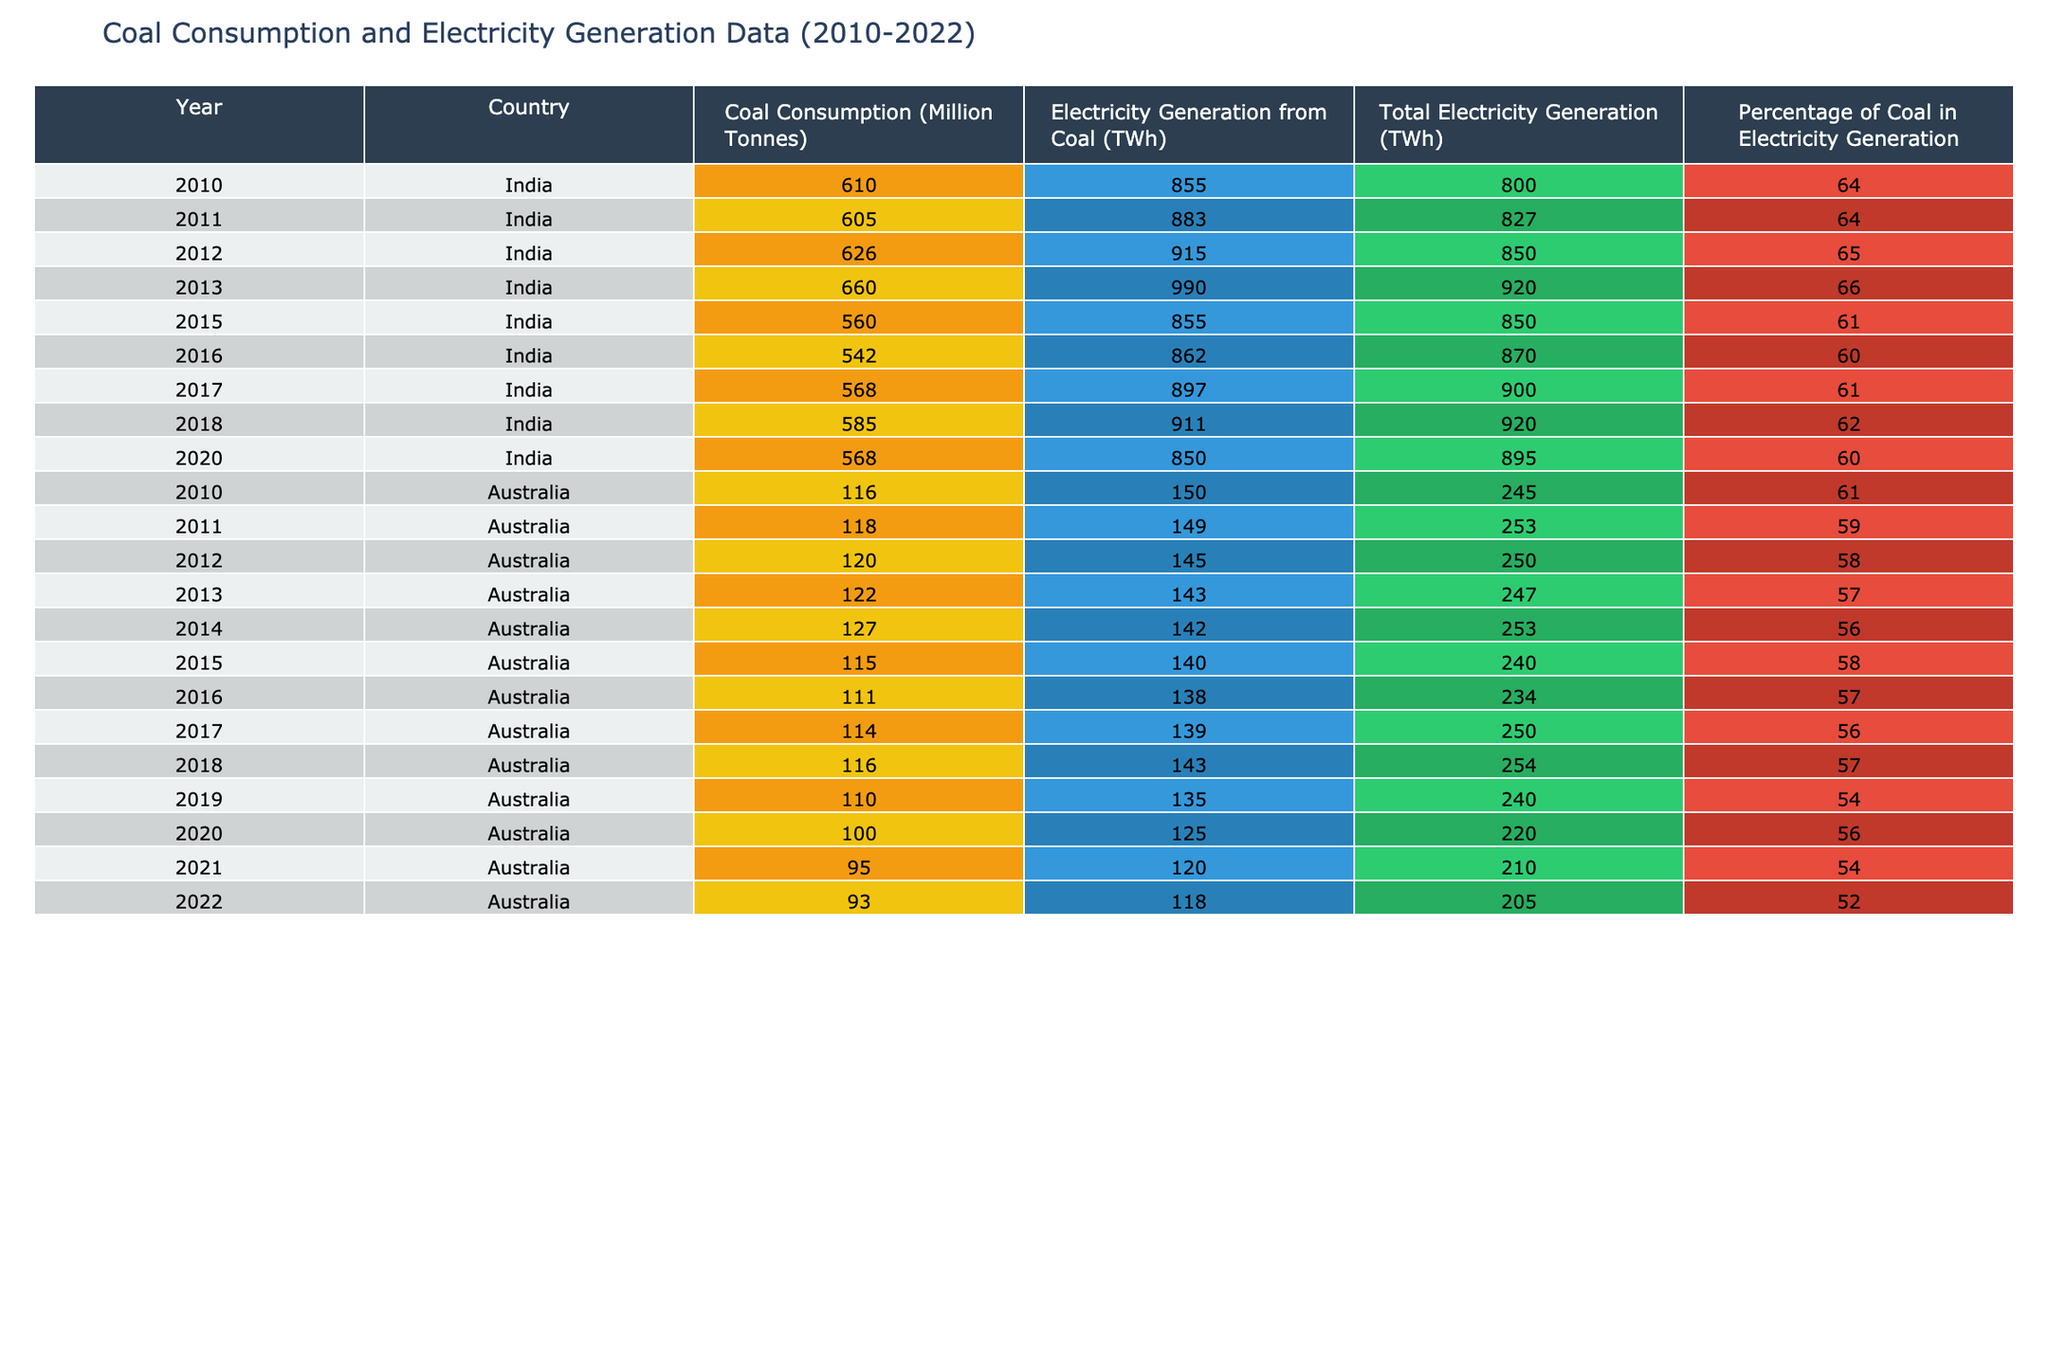What was the highest coal consumption recorded in India from 2010 to 2022? The table shows coal consumption by year for India. Looking through the data, the highest value of coal consumption in India is 660 million tonnes, recorded in 2013.
Answer: 660 million tonnes In which year did Australia have the lowest electricity generation from coal? By examining the electricity generation figures for Australia, the lowest recorded value is 118 TWh in 2022.
Answer: 118 TWh What percentage of Australia's electricity generation was from coal in 2020? According to the table, in 2020, Australia's percentage of coal in electricity generation is recorded as 56%.
Answer: 56% How many TWh of electricity was generated from coal in India in 2015? From the provided data, India generated 855 TWh of electricity from coal in 2015.
Answer: 855 TWh What is the average coal consumption for India from 2010 to 2022? Adding the coal consumption values for India between 2010 and 2022 gives a total of 3,750 million tonnes. There are 8 years of data, so the average is 3,750 / 8 = 468.75.
Answer: 468.75 million tonnes Did Australia's percentage of coal in electricity generation decrease from 2010 to 2022? Examining the yearly percentage data, it was 61% in 2010 and dropped to 52% in 2022. This indicates a decrease.
Answer: Yes What was the total electricity generation from coal in Australia in 2018? The table indicates that Australia generated 143 TWh from coal in 2018.
Answer: 143 TWh How much did India's electricity generation from coal change from 2010 to 2018? In 2010, the generation was 855 TWh, and by 2018 it was 911 TWh. The change is 911 - 855 = 56 TWh increase.
Answer: 56 TWh increase Which country had a higher total electricity generation from coal in 2012? The table shows India at 915 TWh and Australia at 145 TWh in 2012. Thus, India had a higher generation.
Answer: India How much coal was consumed in Australia from 2010 to 2022 combined? Summing the values from the Australian data for the years listed gives a total of 1,408 million tonnes.
Answer: 1,408 million tonnes What was the trend of coal consumption in India from 2010 to 2017? The values showed fluctuations, with increasing consumption from 610 million tonnes in 2010 to 660 million tonnes in 2013, and a decrease to 568 million tonnes in 2017. The trend is generally upward, followed by a decrease.
Answer: Increasing then decreasing 